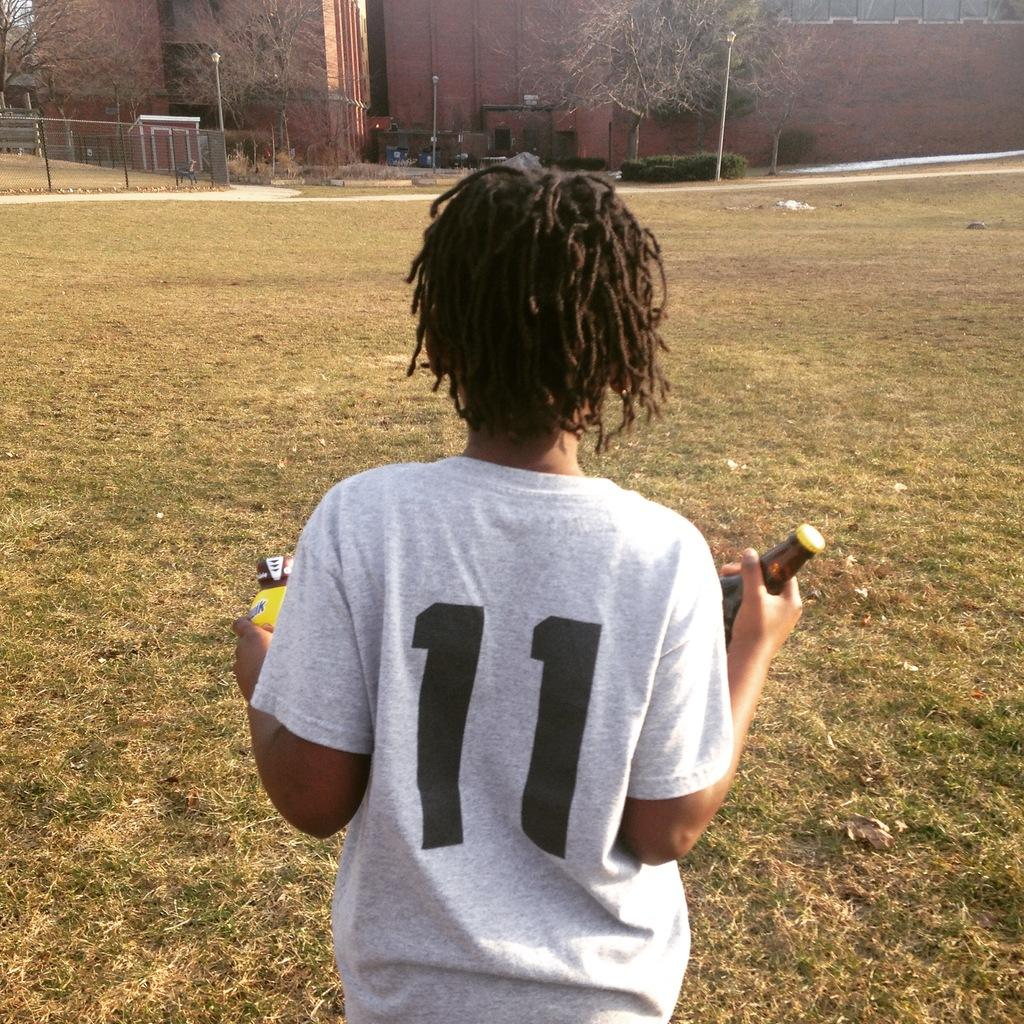Provide a one-sentence caption for the provided image. A youth athlete wearing number 11 holding Nesquik and a bottle of beer. 